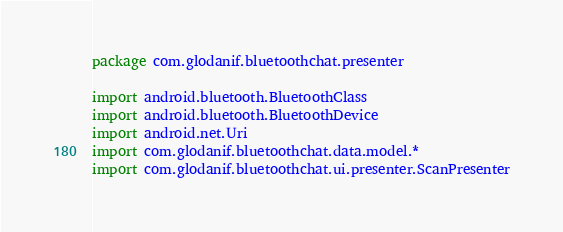<code> <loc_0><loc_0><loc_500><loc_500><_Kotlin_>package com.glodanif.bluetoothchat.presenter

import android.bluetooth.BluetoothClass
import android.bluetooth.BluetoothDevice
import android.net.Uri
import com.glodanif.bluetoothchat.data.model.*
import com.glodanif.bluetoothchat.ui.presenter.ScanPresenter</code> 